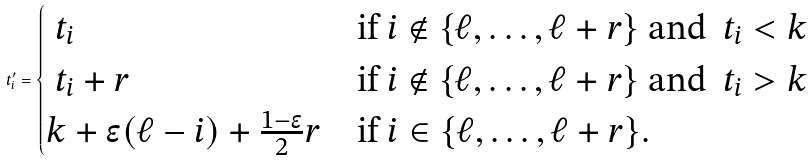Convert formula to latex. <formula><loc_0><loc_0><loc_500><loc_500>\ t ^ { \prime } _ { i } = \begin{cases} \ t _ { i } & \text {if } i \notin \{ \ell , \dots , \ell + r \} \text { and } \ t _ { i } < k \\ \ t _ { i } + r & \text {if } i \notin \{ \ell , \dots , \ell + r \} \text { and } \ t _ { i } > k \\ k + \epsilon ( \ell - i ) + \frac { 1 - \epsilon } { 2 } r & \text {if } i \in \{ \ell , \dots , \ell + r \} . \end{cases}</formula> 